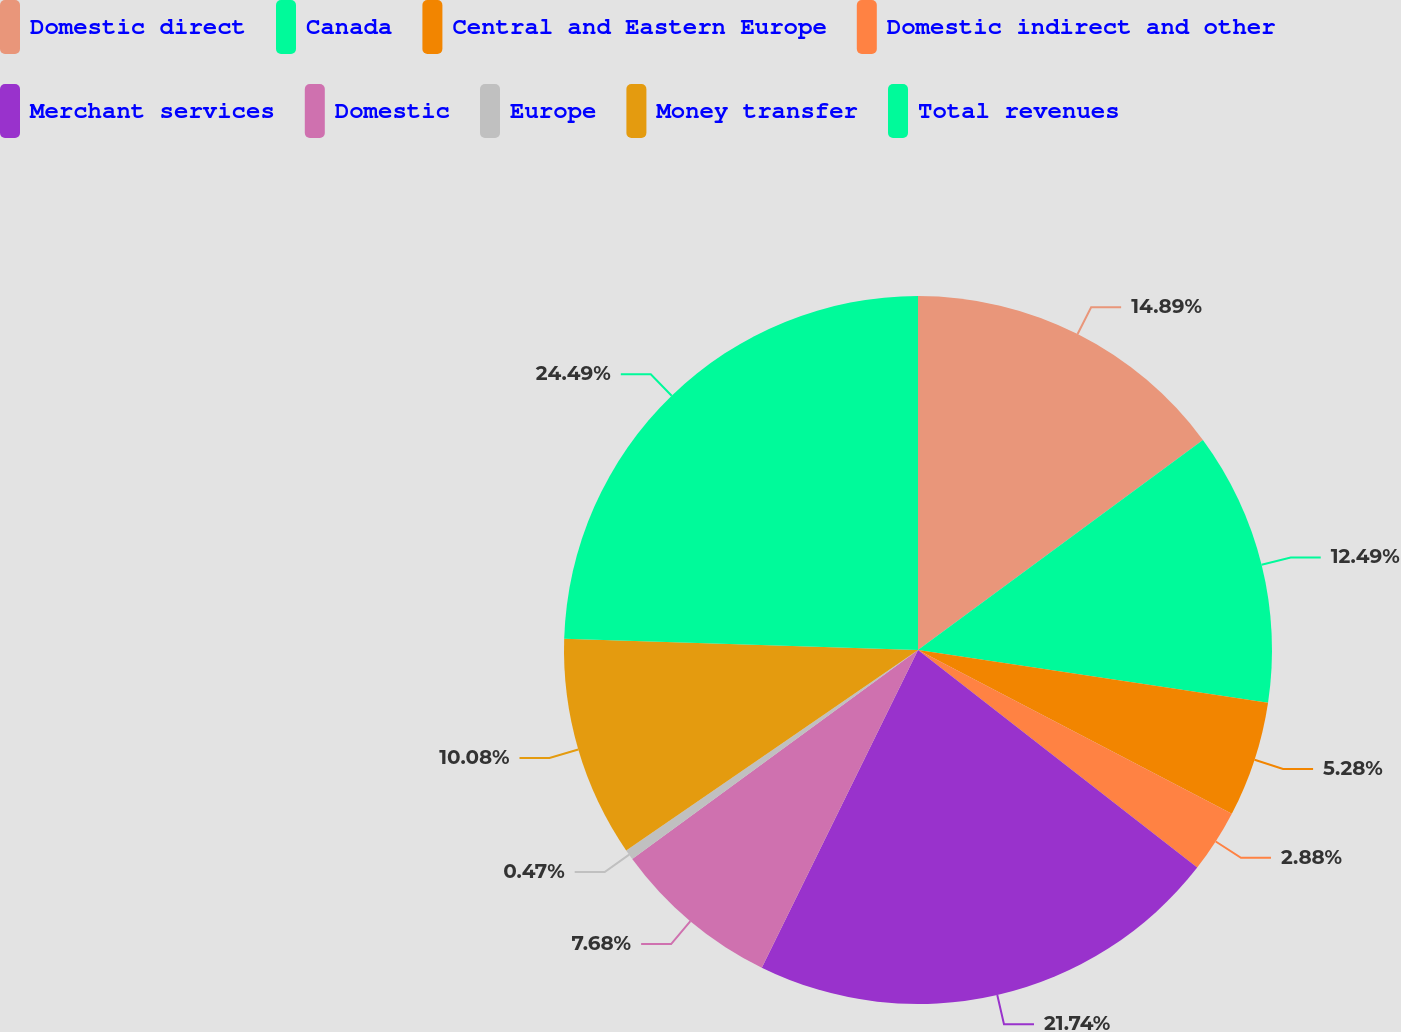Convert chart. <chart><loc_0><loc_0><loc_500><loc_500><pie_chart><fcel>Domestic direct<fcel>Canada<fcel>Central and Eastern Europe<fcel>Domestic indirect and other<fcel>Merchant services<fcel>Domestic<fcel>Europe<fcel>Money transfer<fcel>Total revenues<nl><fcel>14.89%<fcel>12.49%<fcel>5.28%<fcel>2.88%<fcel>21.74%<fcel>7.68%<fcel>0.47%<fcel>10.08%<fcel>24.5%<nl></chart> 